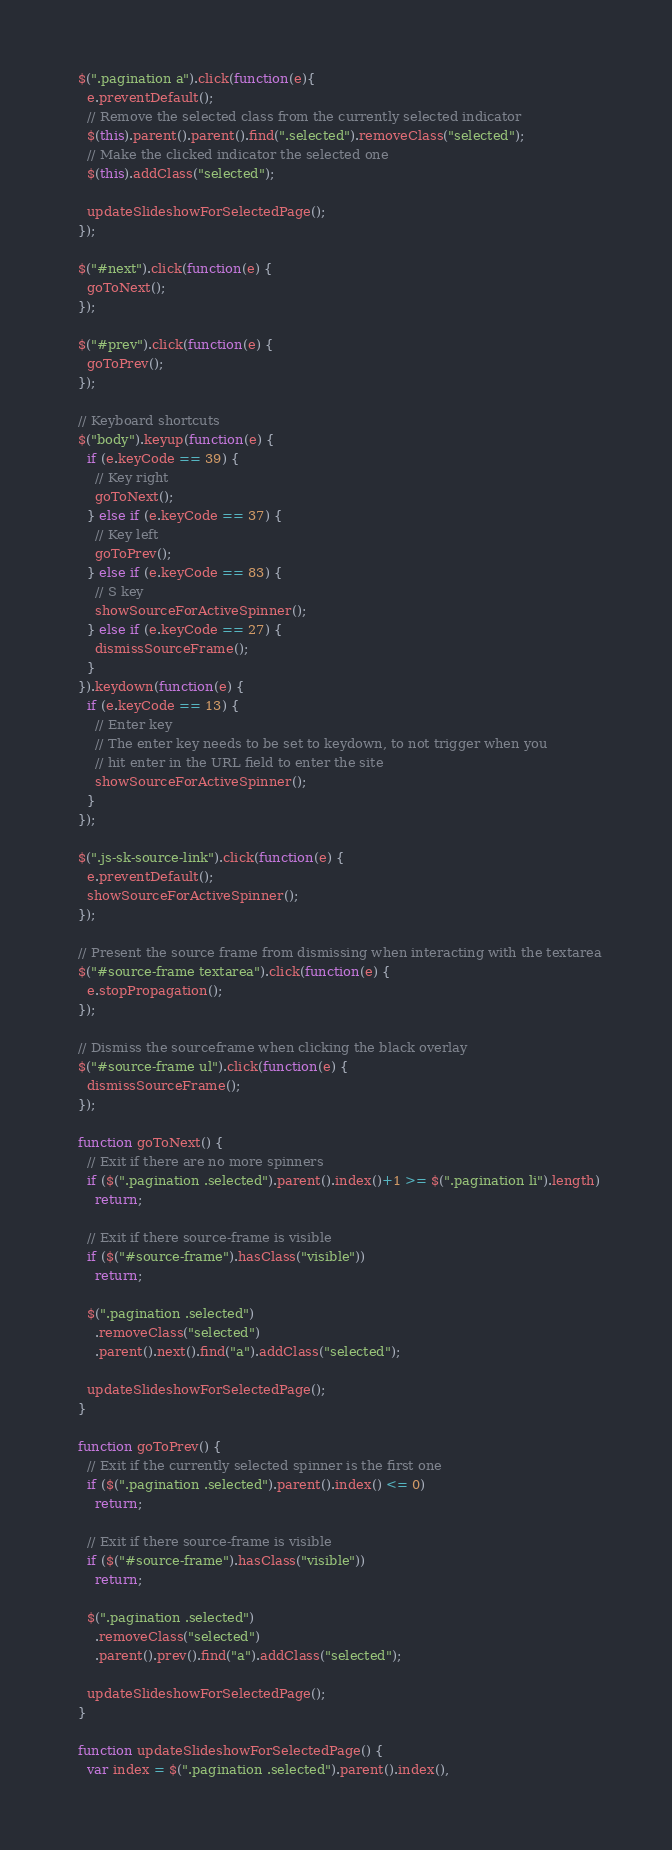<code> <loc_0><loc_0><loc_500><loc_500><_JavaScript_>
  $(".pagination a").click(function(e){
    e.preventDefault();
    // Remove the selected class from the currently selected indicator
    $(this).parent().parent().find(".selected").removeClass("selected");
    // Make the clicked indicator the selected one
    $(this).addClass("selected");
    
    updateSlideshowForSelectedPage();
  });
  
  $("#next").click(function(e) {
    goToNext();
  });
  
  $("#prev").click(function(e) {
    goToPrev();
  });

  // Keyboard shortcuts
  $("body").keyup(function(e) {
    if (e.keyCode == 39) {
      // Key right
      goToNext();
    } else if (e.keyCode == 37) {
      // Key left
      goToPrev();
    } else if (e.keyCode == 83) {
      // S key
      showSourceForActiveSpinner();
    } else if (e.keyCode == 27) {
      dismissSourceFrame();
    }
  }).keydown(function(e) {
    if (e.keyCode == 13) {
      // Enter key
      // The enter key needs to be set to keydown, to not trigger when you
      // hit enter in the URL field to enter the site
      showSourceForActiveSpinner();
    }
  });

  $(".js-sk-source-link").click(function(e) {
    e.preventDefault();
    showSourceForActiveSpinner();
  });

  // Present the source frame from dismissing when interacting with the textarea
  $("#source-frame textarea").click(function(e) {
    e.stopPropagation();
  });

  // Dismiss the sourceframe when clicking the black overlay
  $("#source-frame ul").click(function(e) {
    dismissSourceFrame();
  });
  
  function goToNext() {
    // Exit if there are no more spinners
    if ($(".pagination .selected").parent().index()+1 >= $(".pagination li").length)
      return;

    // Exit if there source-frame is visible
    if ($("#source-frame").hasClass("visible"))
      return;

    $(".pagination .selected")
      .removeClass("selected")
      .parent().next().find("a").addClass("selected");
    
    updateSlideshowForSelectedPage();
  }
  
  function goToPrev() {
    // Exit if the currently selected spinner is the first one
    if ($(".pagination .selected").parent().index() <= 0)
      return;

    // Exit if there source-frame is visible
    if ($("#source-frame").hasClass("visible"))
      return;

    $(".pagination .selected")
      .removeClass("selected")
      .parent().prev().find("a").addClass("selected");
    
    updateSlideshowForSelectedPage();
  }
  
  function updateSlideshowForSelectedPage() {
    var index = $(".pagination .selected").parent().index(),</code> 